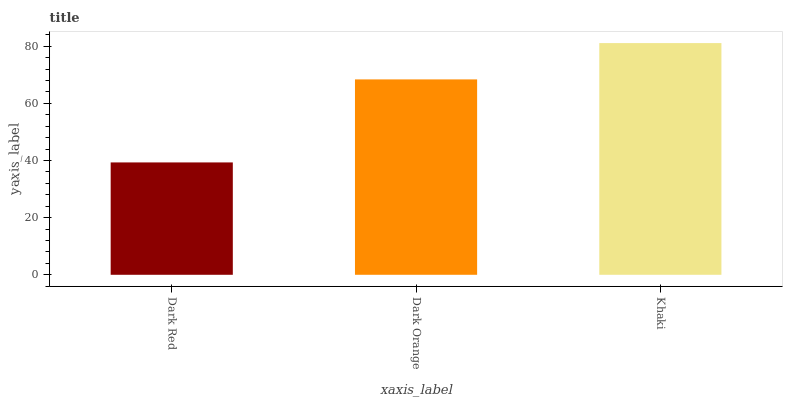Is Dark Red the minimum?
Answer yes or no. Yes. Is Khaki the maximum?
Answer yes or no. Yes. Is Dark Orange the minimum?
Answer yes or no. No. Is Dark Orange the maximum?
Answer yes or no. No. Is Dark Orange greater than Dark Red?
Answer yes or no. Yes. Is Dark Red less than Dark Orange?
Answer yes or no. Yes. Is Dark Red greater than Dark Orange?
Answer yes or no. No. Is Dark Orange less than Dark Red?
Answer yes or no. No. Is Dark Orange the high median?
Answer yes or no. Yes. Is Dark Orange the low median?
Answer yes or no. Yes. Is Dark Red the high median?
Answer yes or no. No. Is Dark Red the low median?
Answer yes or no. No. 